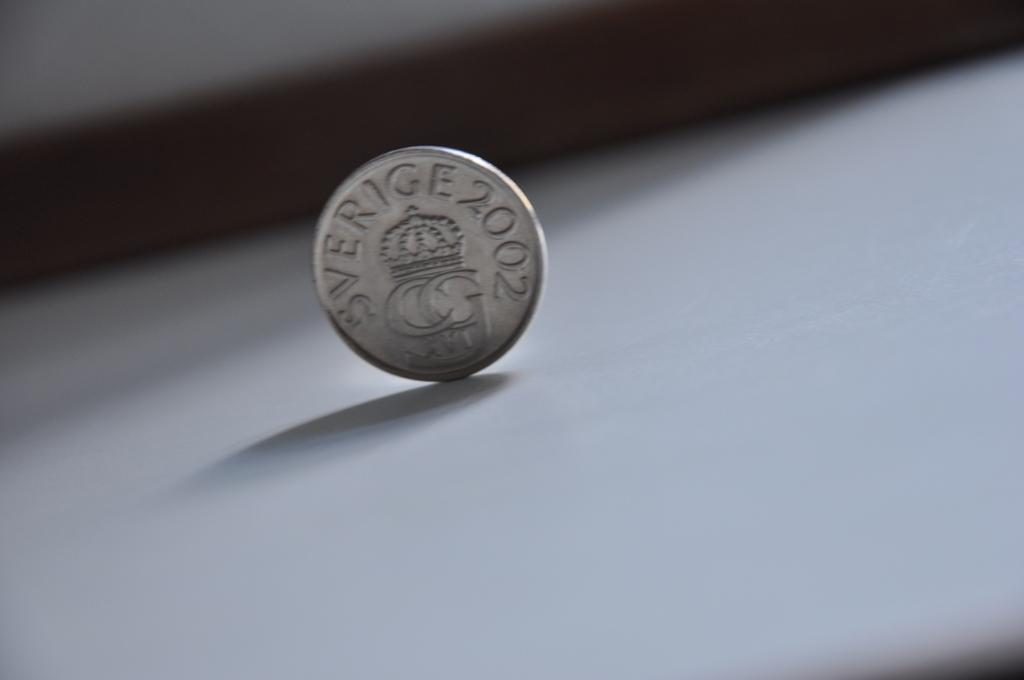What year was the coin made?
Provide a succinct answer. 2002. What letters are under the crown?
Provide a succinct answer. Cg. 